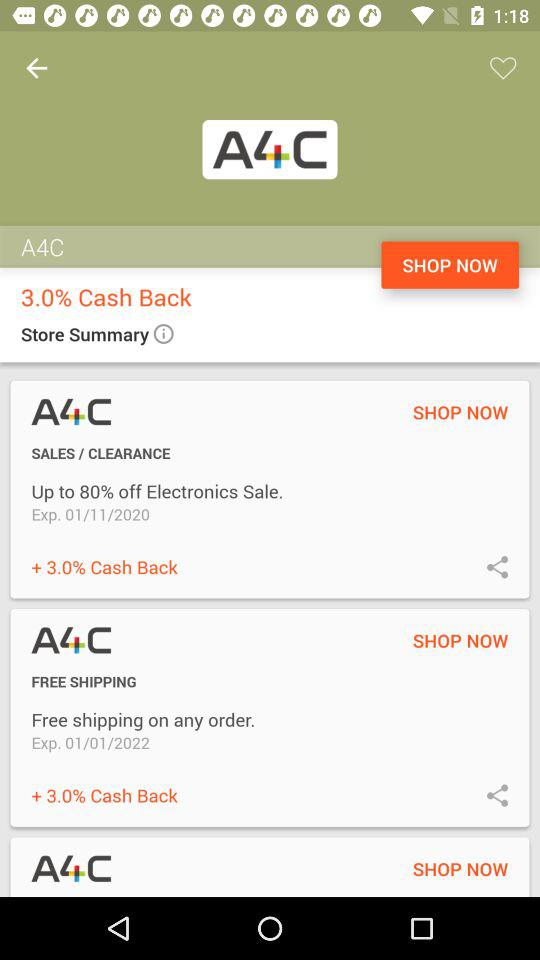What is the organization name? The organization name is "A4C". 